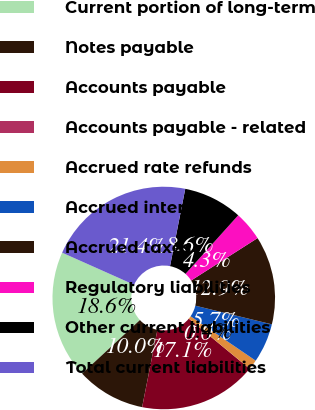Convert chart to OTSL. <chart><loc_0><loc_0><loc_500><loc_500><pie_chart><fcel>Current portion of long-term<fcel>Notes payable<fcel>Accounts payable<fcel>Accounts payable - related<fcel>Accrued rate refunds<fcel>Accrued interest<fcel>Accrued taxes<fcel>Regulatory liabilities<fcel>Other current liabilities<fcel>Total current liabilities<nl><fcel>18.56%<fcel>10.0%<fcel>17.14%<fcel>0.01%<fcel>1.44%<fcel>5.72%<fcel>12.85%<fcel>4.29%<fcel>8.57%<fcel>21.42%<nl></chart> 